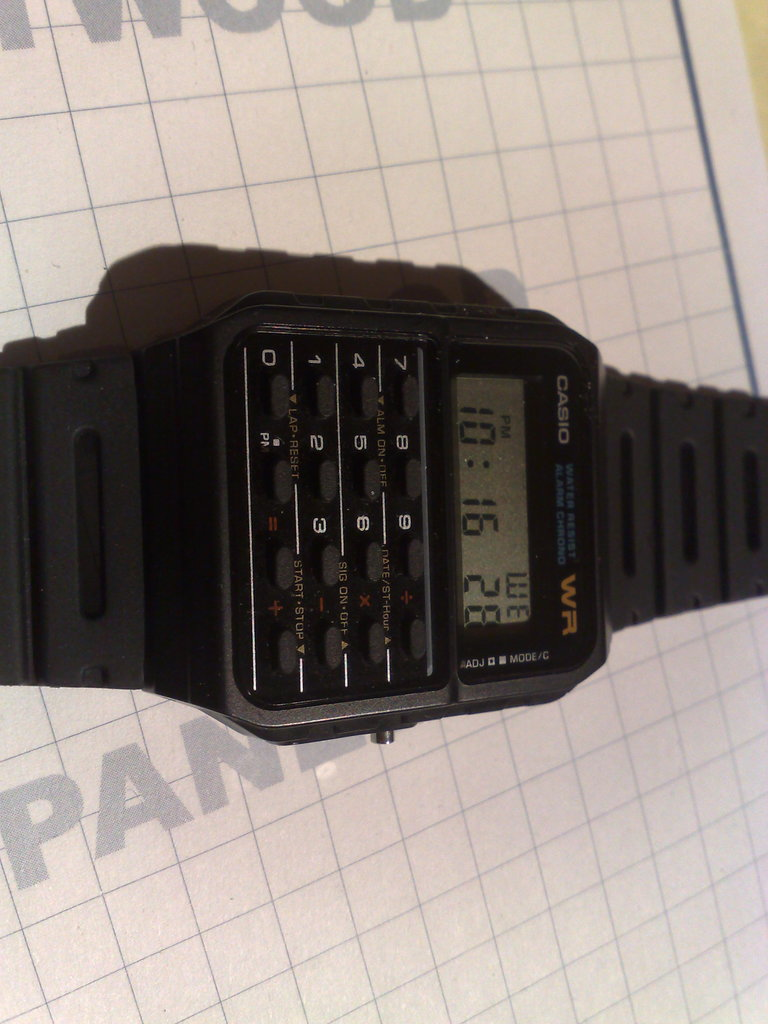What era does this type of watch belong to, and what functionality is unique to it? This type of watch hails from the late 20th century, a hallmark of 1980s technology, featuring a unique built-in calculator, making it a popular accessory for those needing quick calculations on the go. 